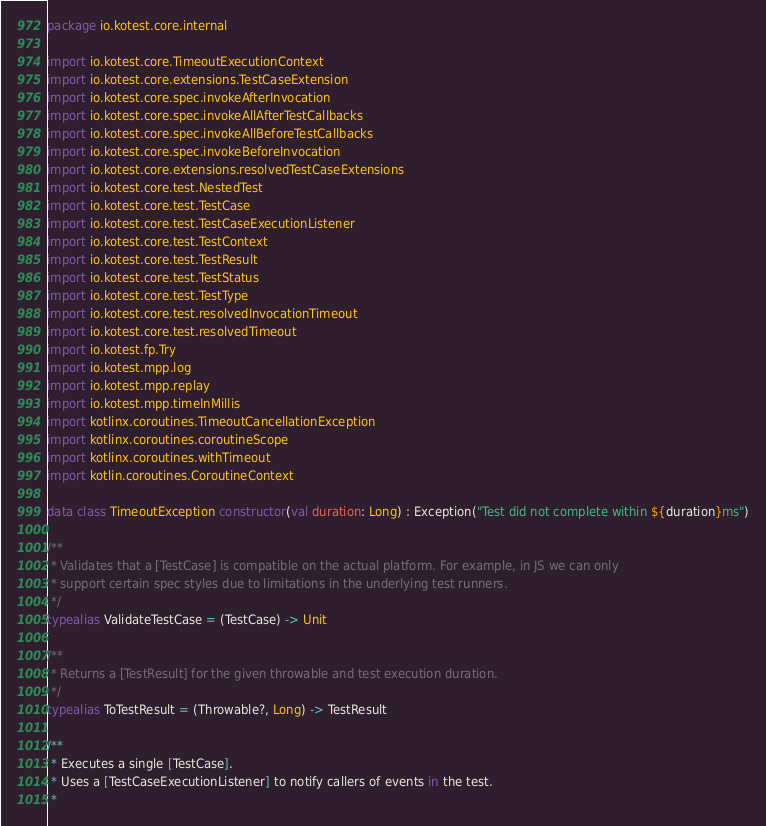Convert code to text. <code><loc_0><loc_0><loc_500><loc_500><_Kotlin_>package io.kotest.core.internal

import io.kotest.core.TimeoutExecutionContext
import io.kotest.core.extensions.TestCaseExtension
import io.kotest.core.spec.invokeAfterInvocation
import io.kotest.core.spec.invokeAllAfterTestCallbacks
import io.kotest.core.spec.invokeAllBeforeTestCallbacks
import io.kotest.core.spec.invokeBeforeInvocation
import io.kotest.core.extensions.resolvedTestCaseExtensions
import io.kotest.core.test.NestedTest
import io.kotest.core.test.TestCase
import io.kotest.core.test.TestCaseExecutionListener
import io.kotest.core.test.TestContext
import io.kotest.core.test.TestResult
import io.kotest.core.test.TestStatus
import io.kotest.core.test.TestType
import io.kotest.core.test.resolvedInvocationTimeout
import io.kotest.core.test.resolvedTimeout
import io.kotest.fp.Try
import io.kotest.mpp.log
import io.kotest.mpp.replay
import io.kotest.mpp.timeInMillis
import kotlinx.coroutines.TimeoutCancellationException
import kotlinx.coroutines.coroutineScope
import kotlinx.coroutines.withTimeout
import kotlin.coroutines.CoroutineContext

data class TimeoutException constructor(val duration: Long) : Exception("Test did not complete within ${duration}ms")

/**
 * Validates that a [TestCase] is compatible on the actual platform. For example, in JS we can only
 * support certain spec styles due to limitations in the underlying test runners.
 */
typealias ValidateTestCase = (TestCase) -> Unit

/**
 * Returns a [TestResult] for the given throwable and test execution duration.
 */
typealias ToTestResult = (Throwable?, Long) -> TestResult

/**
 * Executes a single [TestCase].
 * Uses a [TestCaseExecutionListener] to notify callers of events in the test.
 *</code> 